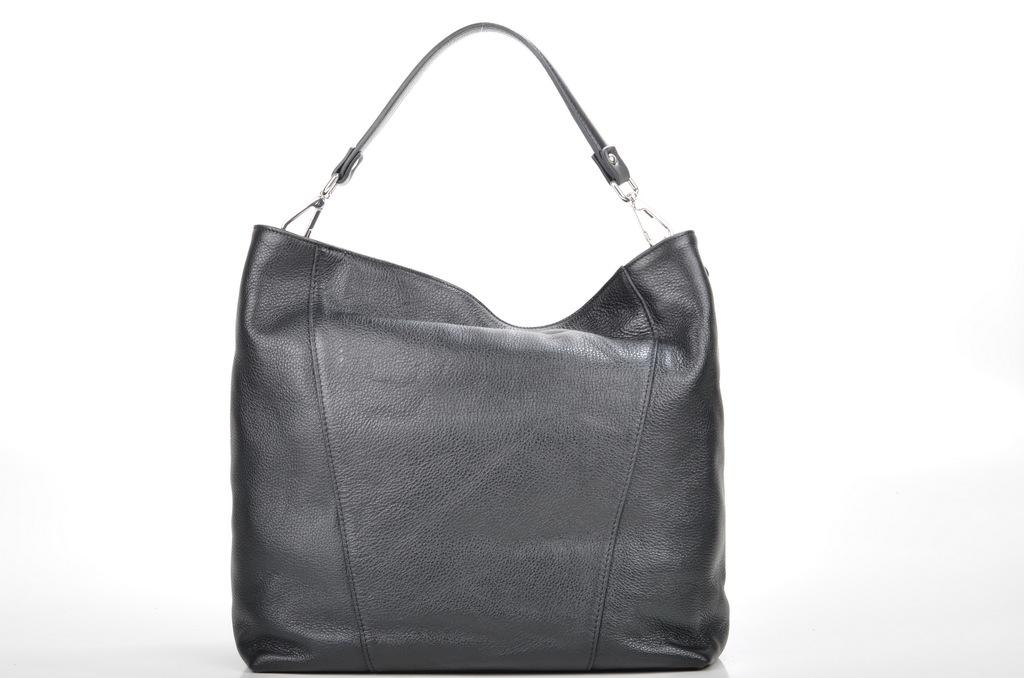What type of handbag is visible in the image? There is a black color handbag in the image. What type of whip is being used to print on the linen in the image? There is no whip, printing, or linen present in the image; it only features a black color handbag. 